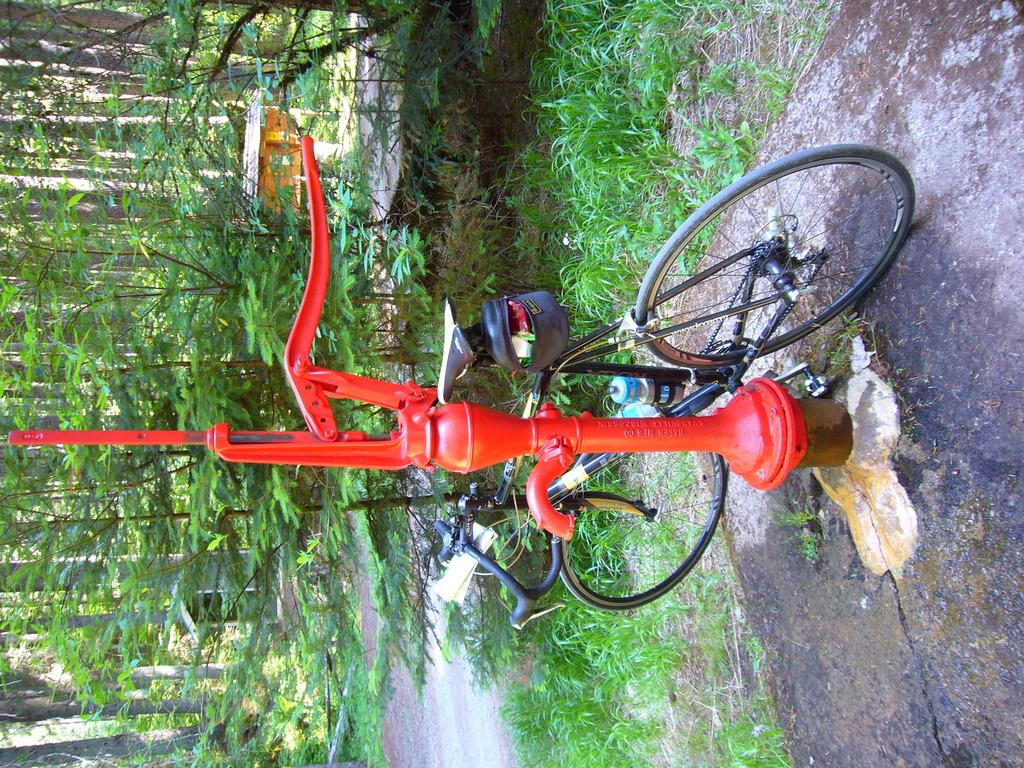What is the main object in the image? There is a hand pump in the image. What else can be seen in the image? There is a bicycle in the image. What is the state of the bicycle? The bicycle is parked. What is located on the left side of the image? There are trees, a house, and grass on the left side of the image. Can you tell me how many pets are swimming in the image? There are no pets or swimming activity present in the image. What type of conversation is happening between the trees and the house in the image? There is no conversation happening between the trees and the house in the image, as they are inanimate objects. 